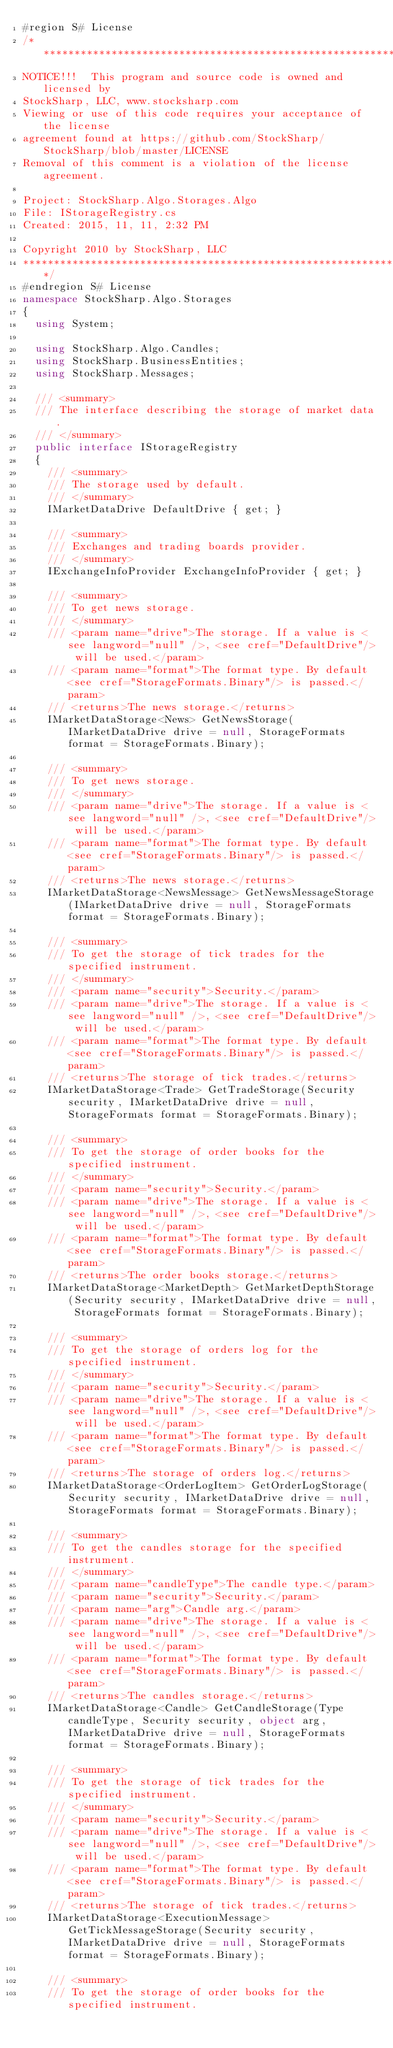Convert code to text. <code><loc_0><loc_0><loc_500><loc_500><_C#_>#region S# License
/******************************************************************************************
NOTICE!!!  This program and source code is owned and licensed by
StockSharp, LLC, www.stocksharp.com
Viewing or use of this code requires your acceptance of the license
agreement found at https://github.com/StockSharp/StockSharp/blob/master/LICENSE
Removal of this comment is a violation of the license agreement.

Project: StockSharp.Algo.Storages.Algo
File: IStorageRegistry.cs
Created: 2015, 11, 11, 2:32 PM

Copyright 2010 by StockSharp, LLC
*******************************************************************************************/
#endregion S# License
namespace StockSharp.Algo.Storages
{
	using System;

	using StockSharp.Algo.Candles;
	using StockSharp.BusinessEntities;
	using StockSharp.Messages;

	/// <summary>
	/// The interface describing the storage of market data.
	/// </summary>
	public interface IStorageRegistry
	{
		/// <summary>
		/// The storage used by default.
		/// </summary>
		IMarketDataDrive DefaultDrive { get; }

		/// <summary>
		/// Exchanges and trading boards provider.
		/// </summary>
		IExchangeInfoProvider ExchangeInfoProvider { get; }

		/// <summary>
		/// To get news storage.
		/// </summary>
		/// <param name="drive">The storage. If a value is <see langword="null" />, <see cref="DefaultDrive"/> will be used.</param>
		/// <param name="format">The format type. By default <see cref="StorageFormats.Binary"/> is passed.</param>
		/// <returns>The news storage.</returns>
		IMarketDataStorage<News> GetNewsStorage(IMarketDataDrive drive = null, StorageFormats format = StorageFormats.Binary);

		/// <summary>
		/// To get news storage.
		/// </summary>
		/// <param name="drive">The storage. If a value is <see langword="null" />, <see cref="DefaultDrive"/> will be used.</param>
		/// <param name="format">The format type. By default <see cref="StorageFormats.Binary"/> is passed.</param>
		/// <returns>The news storage.</returns>
		IMarketDataStorage<NewsMessage> GetNewsMessageStorage(IMarketDataDrive drive = null, StorageFormats format = StorageFormats.Binary);

		/// <summary>
		/// To get the storage of tick trades for the specified instrument.
		/// </summary>
		/// <param name="security">Security.</param>
		/// <param name="drive">The storage. If a value is <see langword="null" />, <see cref="DefaultDrive"/> will be used.</param>
		/// <param name="format">The format type. By default <see cref="StorageFormats.Binary"/> is passed.</param>
		/// <returns>The storage of tick trades.</returns>
		IMarketDataStorage<Trade> GetTradeStorage(Security security, IMarketDataDrive drive = null, StorageFormats format = StorageFormats.Binary);

		/// <summary>
		/// To get the storage of order books for the specified instrument.
		/// </summary>
		/// <param name="security">Security.</param>
		/// <param name="drive">The storage. If a value is <see langword="null" />, <see cref="DefaultDrive"/> will be used.</param>
		/// <param name="format">The format type. By default <see cref="StorageFormats.Binary"/> is passed.</param>
		/// <returns>The order books storage.</returns>
		IMarketDataStorage<MarketDepth> GetMarketDepthStorage(Security security, IMarketDataDrive drive = null, StorageFormats format = StorageFormats.Binary);

		/// <summary>
		/// To get the storage of orders log for the specified instrument.
		/// </summary>
		/// <param name="security">Security.</param>
		/// <param name="drive">The storage. If a value is <see langword="null" />, <see cref="DefaultDrive"/> will be used.</param>
		/// <param name="format">The format type. By default <see cref="StorageFormats.Binary"/> is passed.</param>
		/// <returns>The storage of orders log.</returns>
		IMarketDataStorage<OrderLogItem> GetOrderLogStorage(Security security, IMarketDataDrive drive = null, StorageFormats format = StorageFormats.Binary);

		/// <summary>
		/// To get the candles storage for the specified instrument.
		/// </summary>
		/// <param name="candleType">The candle type.</param>
		/// <param name="security">Security.</param>
		/// <param name="arg">Candle arg.</param>
		/// <param name="drive">The storage. If a value is <see langword="null" />, <see cref="DefaultDrive"/> will be used.</param>
		/// <param name="format">The format type. By default <see cref="StorageFormats.Binary"/> is passed.</param>
		/// <returns>The candles storage.</returns>
		IMarketDataStorage<Candle> GetCandleStorage(Type candleType, Security security, object arg, IMarketDataDrive drive = null, StorageFormats format = StorageFormats.Binary);

		/// <summary>
		/// To get the storage of tick trades for the specified instrument.
		/// </summary>
		/// <param name="security">Security.</param>
		/// <param name="drive">The storage. If a value is <see langword="null" />, <see cref="DefaultDrive"/> will be used.</param>
		/// <param name="format">The format type. By default <see cref="StorageFormats.Binary"/> is passed.</param>
		/// <returns>The storage of tick trades.</returns>
		IMarketDataStorage<ExecutionMessage> GetTickMessageStorage(Security security, IMarketDataDrive drive = null, StorageFormats format = StorageFormats.Binary);

		/// <summary>
		/// To get the storage of order books for the specified instrument.</code> 